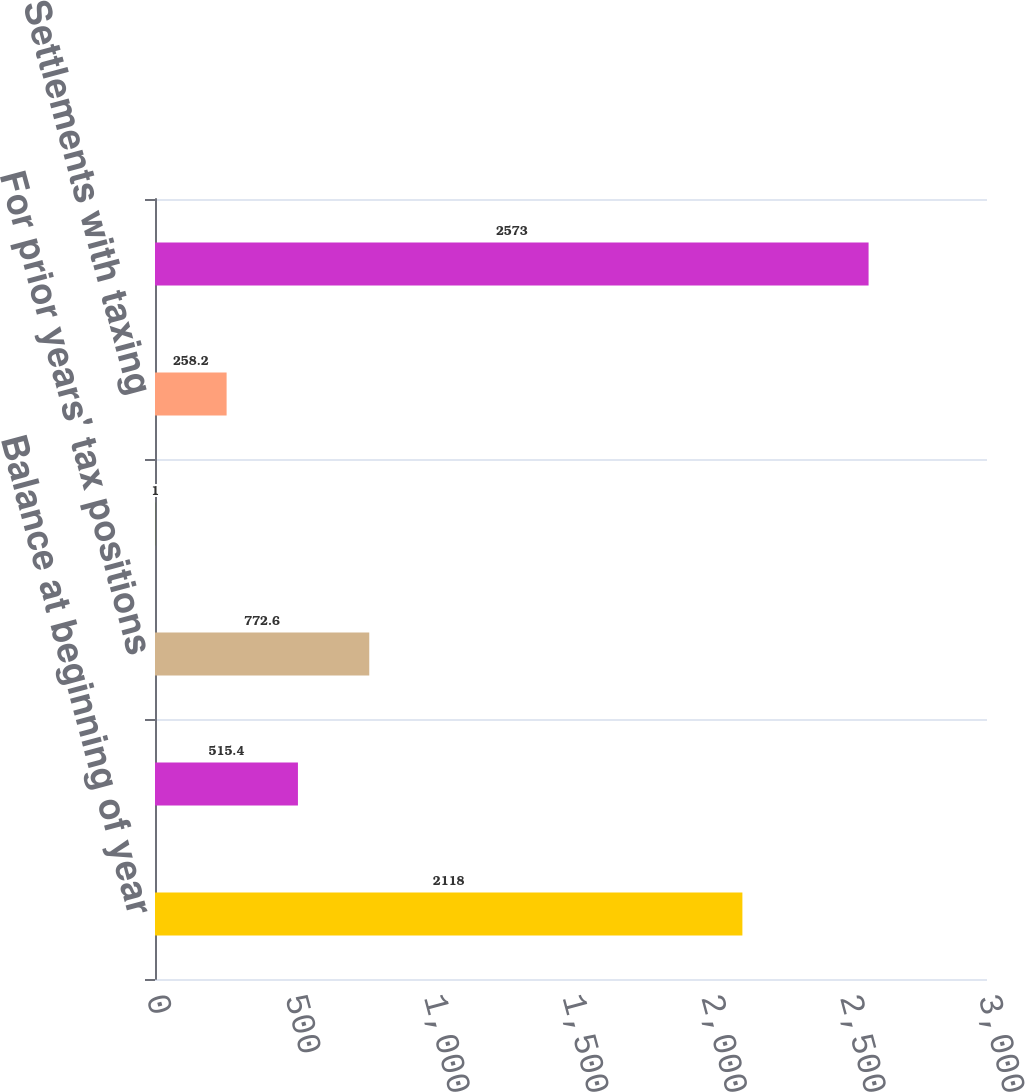Convert chart to OTSL. <chart><loc_0><loc_0><loc_500><loc_500><bar_chart><fcel>Balance at beginning of year<fcel>For current year's tax<fcel>For prior years' tax positions<fcel>Statute of limitations<fcel>Settlements with taxing<fcel>Balance at end of year<nl><fcel>2118<fcel>515.4<fcel>772.6<fcel>1<fcel>258.2<fcel>2573<nl></chart> 